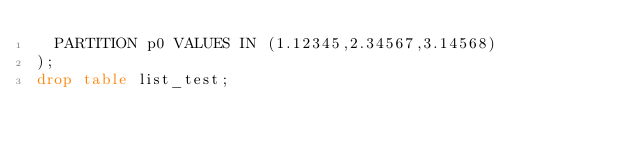<code> <loc_0><loc_0><loc_500><loc_500><_SQL_>	PARTITION p0 VALUES IN (1.12345,2.34567,3.14568)
);
drop table list_test;
</code> 